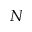Convert formula to latex. <formula><loc_0><loc_0><loc_500><loc_500>N</formula> 